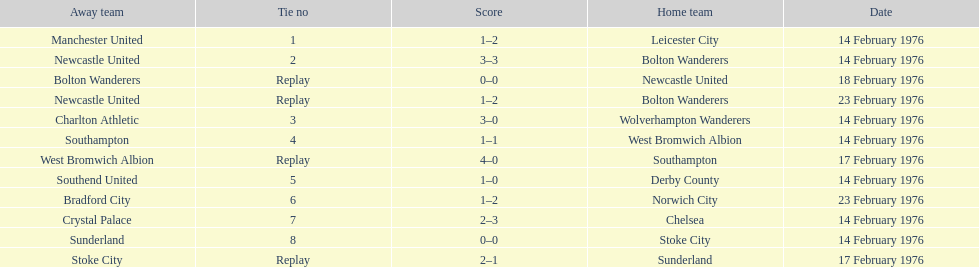Who had a better score, manchester united or wolverhampton wanderers? Wolverhampton Wanderers. 